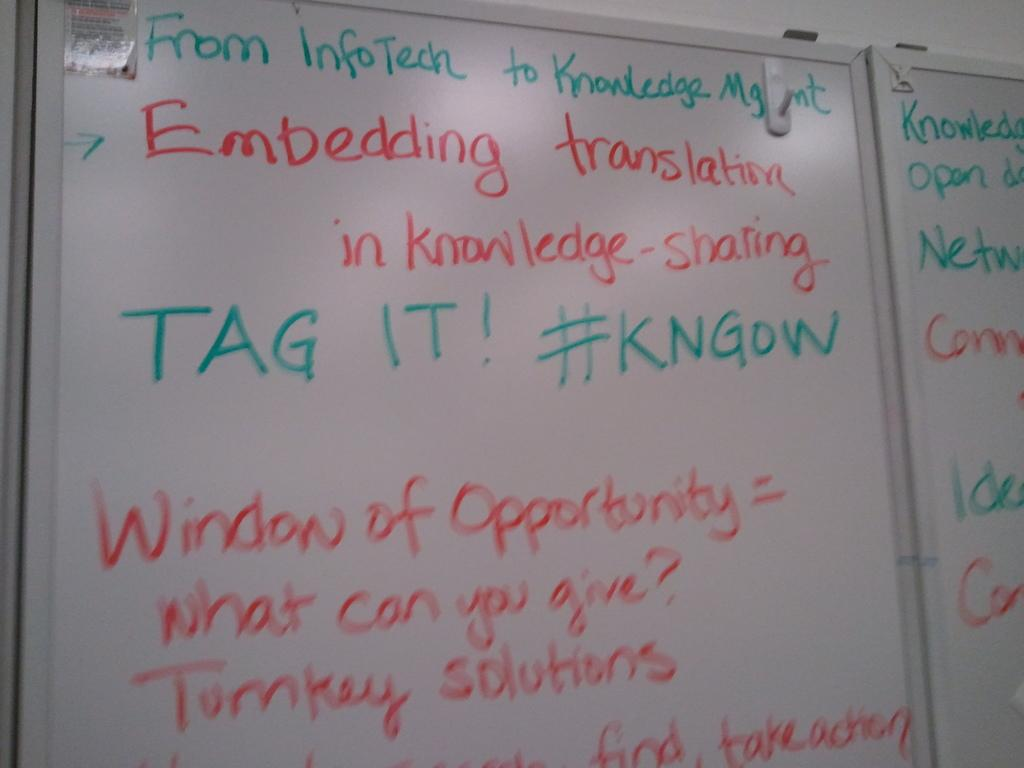<image>
Relay a brief, clear account of the picture shown. White board with lecture titled "From infoTech to Knowledge Mgmt" on it. 